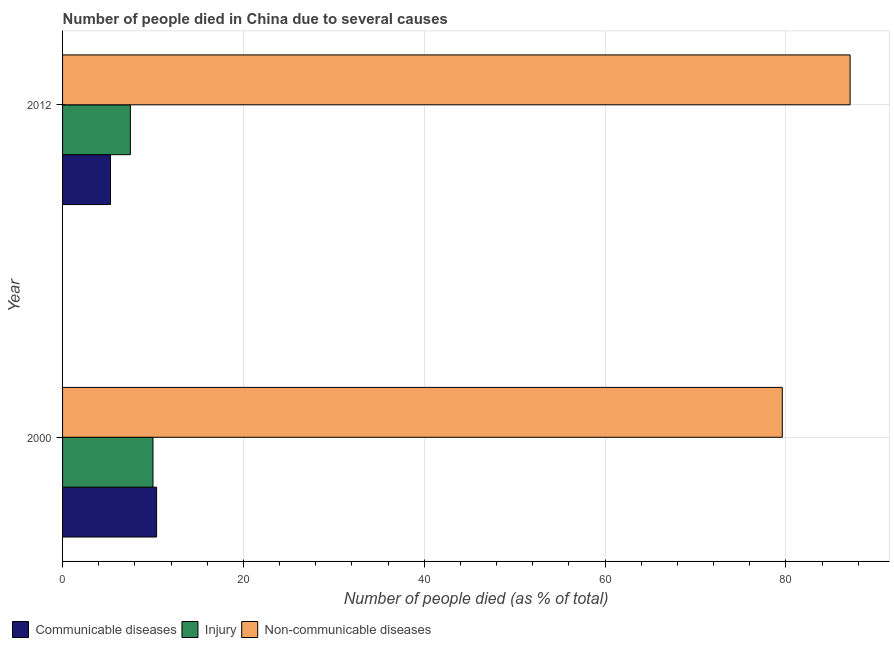How many groups of bars are there?
Offer a terse response. 2. How many bars are there on the 1st tick from the bottom?
Make the answer very short. 3. In how many cases, is the number of bars for a given year not equal to the number of legend labels?
Provide a short and direct response. 0. What is the number of people who died of communicable diseases in 2012?
Make the answer very short. 5.3. Across all years, what is the maximum number of people who died of communicable diseases?
Keep it short and to the point. 10.4. Across all years, what is the minimum number of people who dies of non-communicable diseases?
Provide a succinct answer. 79.6. In which year was the number of people who dies of non-communicable diseases maximum?
Make the answer very short. 2012. In which year was the number of people who died of communicable diseases minimum?
Your answer should be very brief. 2012. What is the total number of people who dies of non-communicable diseases in the graph?
Offer a terse response. 166.7. What is the difference between the number of people who died of communicable diseases in 2000 and that in 2012?
Give a very brief answer. 5.1. What is the difference between the number of people who dies of non-communicable diseases in 2000 and the number of people who died of communicable diseases in 2012?
Your answer should be compact. 74.3. What is the average number of people who died of communicable diseases per year?
Keep it short and to the point. 7.85. In the year 2012, what is the difference between the number of people who died of communicable diseases and number of people who died of injury?
Give a very brief answer. -2.2. In how many years, is the number of people who died of communicable diseases greater than 52 %?
Your answer should be compact. 0. What is the ratio of the number of people who died of injury in 2000 to that in 2012?
Give a very brief answer. 1.33. Is the number of people who died of injury in 2000 less than that in 2012?
Give a very brief answer. No. Is the difference between the number of people who died of communicable diseases in 2000 and 2012 greater than the difference between the number of people who dies of non-communicable diseases in 2000 and 2012?
Ensure brevity in your answer.  Yes. What does the 3rd bar from the top in 2000 represents?
Offer a very short reply. Communicable diseases. What does the 1st bar from the bottom in 2000 represents?
Offer a terse response. Communicable diseases. Is it the case that in every year, the sum of the number of people who died of communicable diseases and number of people who died of injury is greater than the number of people who dies of non-communicable diseases?
Your answer should be compact. No. What is the difference between two consecutive major ticks on the X-axis?
Ensure brevity in your answer.  20. How many legend labels are there?
Make the answer very short. 3. What is the title of the graph?
Keep it short and to the point. Number of people died in China due to several causes. What is the label or title of the X-axis?
Ensure brevity in your answer.  Number of people died (as % of total). What is the label or title of the Y-axis?
Your answer should be compact. Year. What is the Number of people died (as % of total) of Communicable diseases in 2000?
Offer a very short reply. 10.4. What is the Number of people died (as % of total) of Injury in 2000?
Your answer should be very brief. 10. What is the Number of people died (as % of total) of Non-communicable diseases in 2000?
Offer a very short reply. 79.6. What is the Number of people died (as % of total) in Injury in 2012?
Make the answer very short. 7.5. What is the Number of people died (as % of total) of Non-communicable diseases in 2012?
Give a very brief answer. 87.1. Across all years, what is the maximum Number of people died (as % of total) in Non-communicable diseases?
Your response must be concise. 87.1. Across all years, what is the minimum Number of people died (as % of total) of Communicable diseases?
Ensure brevity in your answer.  5.3. Across all years, what is the minimum Number of people died (as % of total) of Non-communicable diseases?
Make the answer very short. 79.6. What is the total Number of people died (as % of total) of Communicable diseases in the graph?
Offer a terse response. 15.7. What is the total Number of people died (as % of total) in Injury in the graph?
Ensure brevity in your answer.  17.5. What is the total Number of people died (as % of total) in Non-communicable diseases in the graph?
Ensure brevity in your answer.  166.7. What is the difference between the Number of people died (as % of total) of Injury in 2000 and that in 2012?
Provide a short and direct response. 2.5. What is the difference between the Number of people died (as % of total) in Non-communicable diseases in 2000 and that in 2012?
Your answer should be compact. -7.5. What is the difference between the Number of people died (as % of total) of Communicable diseases in 2000 and the Number of people died (as % of total) of Non-communicable diseases in 2012?
Keep it short and to the point. -76.7. What is the difference between the Number of people died (as % of total) in Injury in 2000 and the Number of people died (as % of total) in Non-communicable diseases in 2012?
Ensure brevity in your answer.  -77.1. What is the average Number of people died (as % of total) of Communicable diseases per year?
Ensure brevity in your answer.  7.85. What is the average Number of people died (as % of total) in Injury per year?
Offer a terse response. 8.75. What is the average Number of people died (as % of total) of Non-communicable diseases per year?
Provide a short and direct response. 83.35. In the year 2000, what is the difference between the Number of people died (as % of total) in Communicable diseases and Number of people died (as % of total) in Non-communicable diseases?
Your response must be concise. -69.2. In the year 2000, what is the difference between the Number of people died (as % of total) of Injury and Number of people died (as % of total) of Non-communicable diseases?
Your response must be concise. -69.6. In the year 2012, what is the difference between the Number of people died (as % of total) of Communicable diseases and Number of people died (as % of total) of Non-communicable diseases?
Keep it short and to the point. -81.8. In the year 2012, what is the difference between the Number of people died (as % of total) in Injury and Number of people died (as % of total) in Non-communicable diseases?
Provide a succinct answer. -79.6. What is the ratio of the Number of people died (as % of total) in Communicable diseases in 2000 to that in 2012?
Your answer should be compact. 1.96. What is the ratio of the Number of people died (as % of total) of Non-communicable diseases in 2000 to that in 2012?
Make the answer very short. 0.91. What is the difference between the highest and the second highest Number of people died (as % of total) of Communicable diseases?
Your answer should be very brief. 5.1. What is the difference between the highest and the second highest Number of people died (as % of total) in Injury?
Keep it short and to the point. 2.5. What is the difference between the highest and the lowest Number of people died (as % of total) in Communicable diseases?
Provide a short and direct response. 5.1. What is the difference between the highest and the lowest Number of people died (as % of total) of Non-communicable diseases?
Provide a succinct answer. 7.5. 